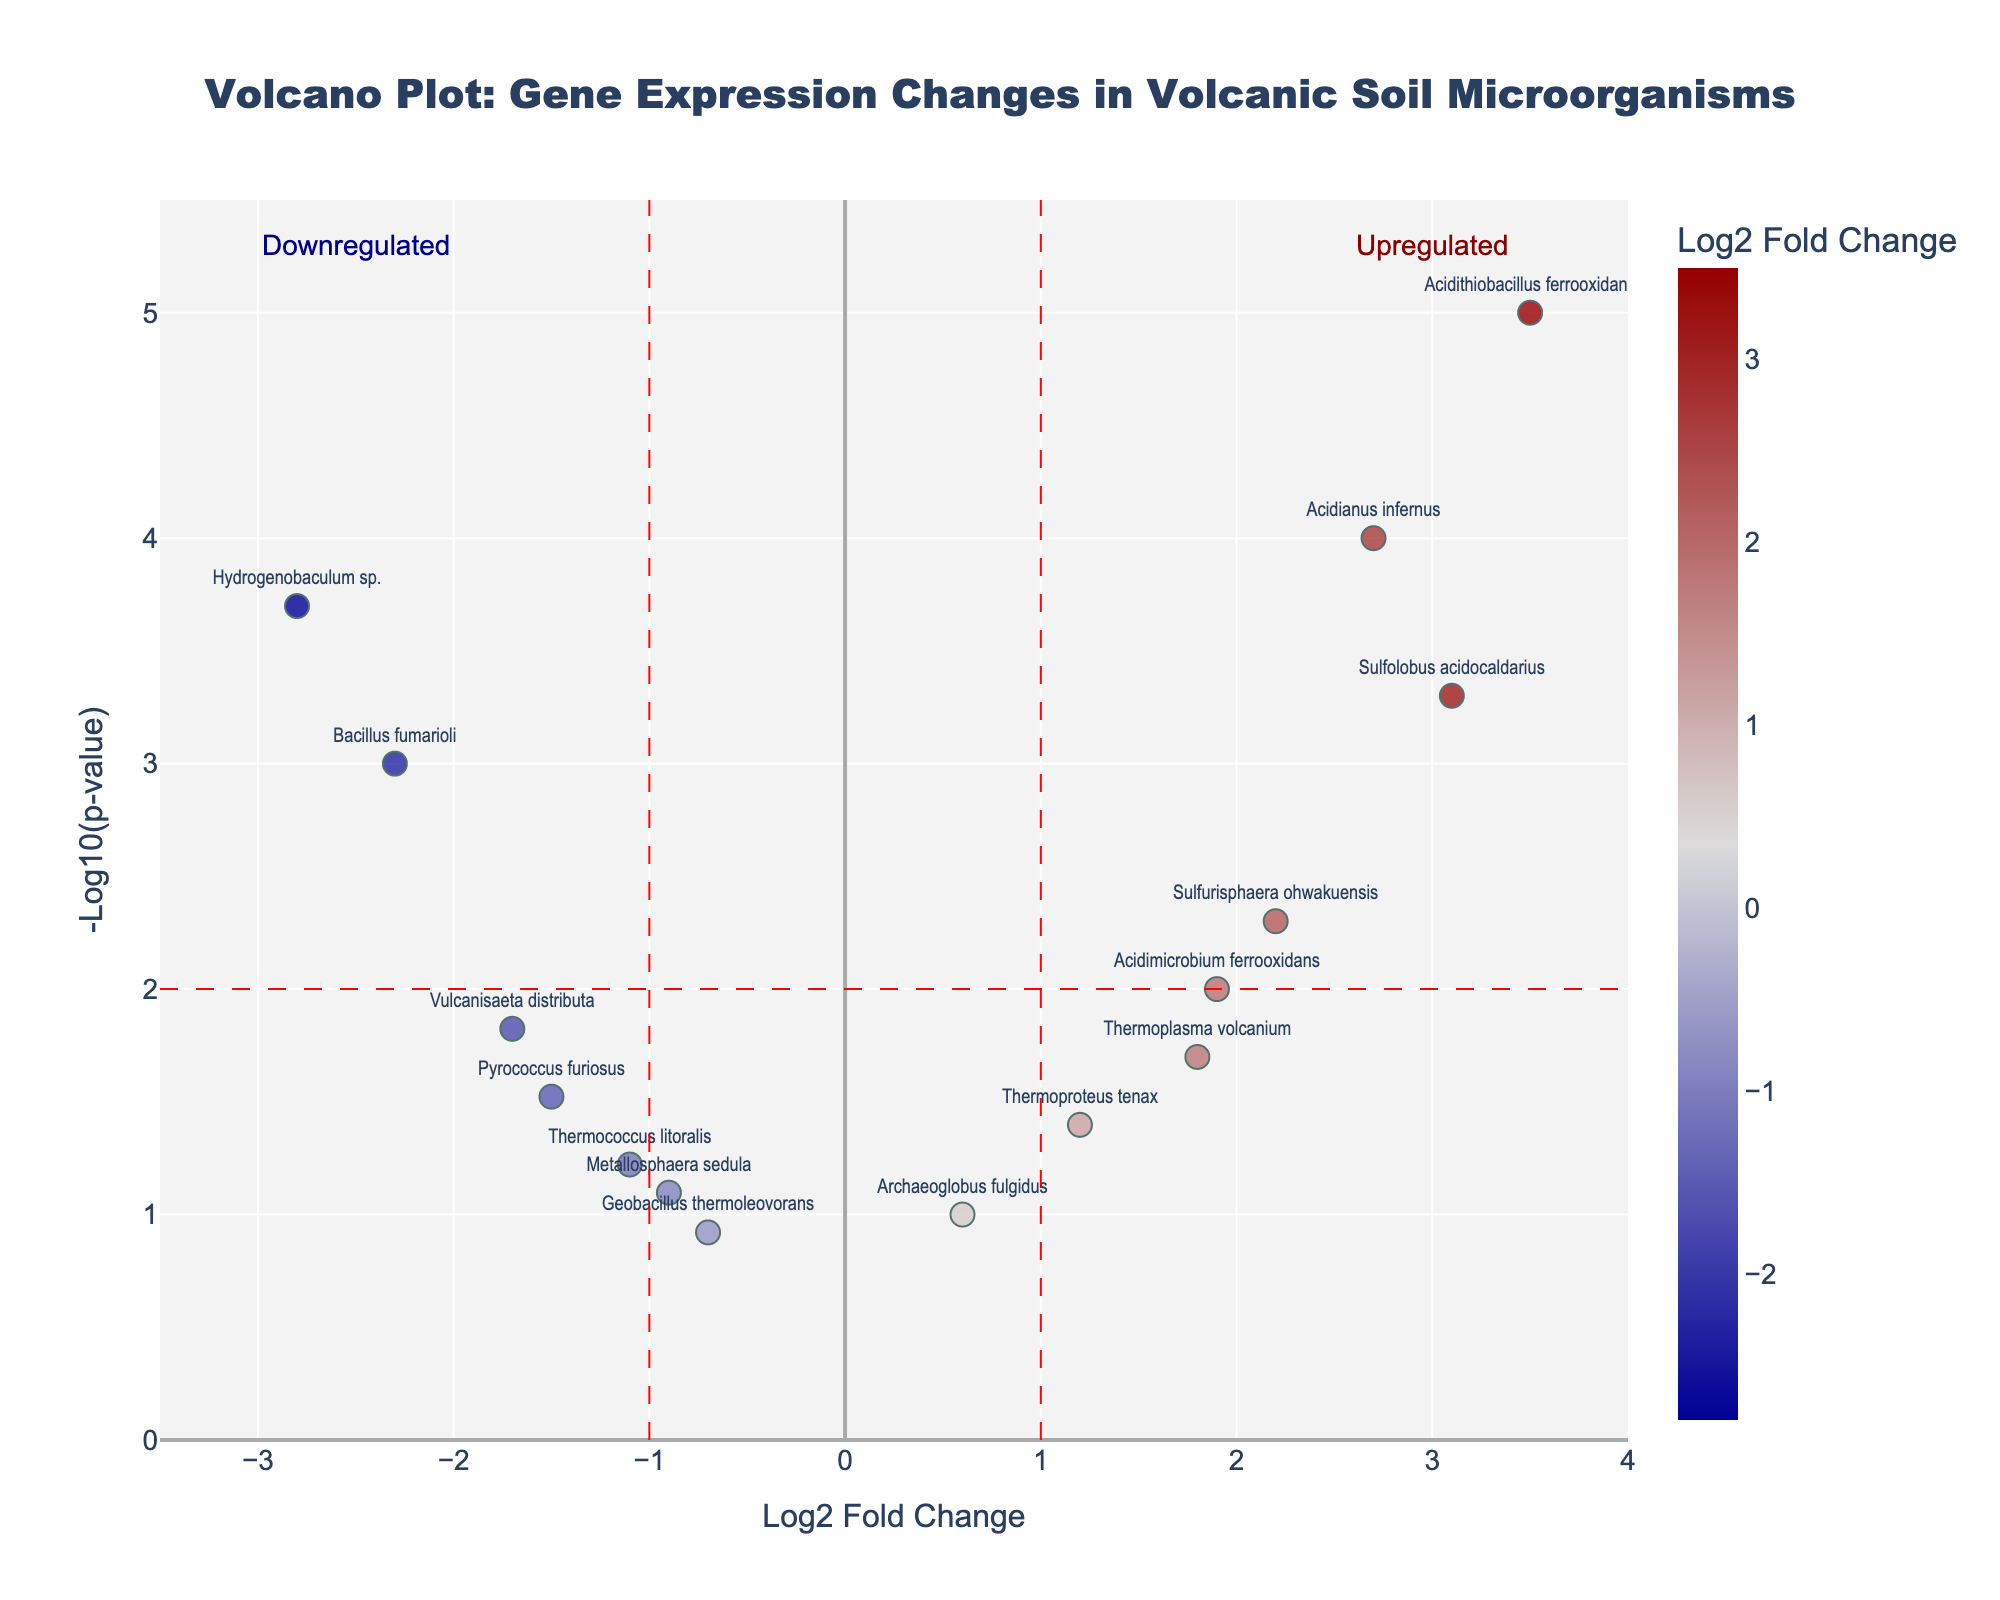What's the title of the plot? The title of the plot is usually at the top center of the figure. Here it's "Volcano Plot: Gene Expression Changes in Volcanic Soil Microorganisms".
Answer: Volcano Plot: Gene Expression Changes in Volcanic Soil Microorganisms What do the x-axis and y-axis represent in this plot? Refer to the axis labels. The x-axis represents ‘Log2 Fold Change’, and the y-axis represents '-Log10(p-value)'.
Answer: x-axis: Log2 Fold Change, y-axis: -Log10(p-value) Which gene has the highest Log2 Fold Change? By looking at the rightmost data points along the x-axis, 'Acidithiobacillus ferrooxidans' has the highest Log2 Fold Change.
Answer: Acidithiobacillus ferrooxidans Which gene is most significantly upregulated? 'Upregulated' refers to positive Log2 Fold Change values; the significance is shown by lower p-values (high -log10(p-value)). 'Acidithiobacillus ferrooxidans' has the highest value on the y-axis among upregulated genes.
Answer: Acidithiobacillus ferrooxidans How many genes have a -Log10(p-value) greater than or equal to 2? Count the data points above the horizontal threshold line y=2. There are 6 genes above this line.
Answer: 6 Among 'Sulfolobus acidocaldarius' and 'Thermoplasma volcanium', which gene is more significant in expression changes? Check which of these two genes has a higher '-Log10(p-value)'. 'Sulfolobus acidocaldarius' has a higher -log10(p-value).
Answer: Sulfolobus acidocaldarius Is 'Hydrogenobaculum sp.' upregulated or downregulated? Check the Log2 Fold Change for 'Hydrogenobaculum sp.'. Since it is negative, the gene is downregulated.
Answer: Downregulated What is the Log2 Fold Change range shown in the plot? Identify the range of the x-axis. The range edges are indicated at -3.5 (left) to 4 (right).
Answer: -3.5 to 4 What is the critical -Log10(p-value) threshold in this plot? Identify the horizontal dashed red line or refer to the added shapes. The threshold for -log10(p-value) is set at 2.
Answer: 2 How many genes are labeled in the plot? Count the number of text labels visible in the figure. There are 14 gene labels visible in the plot.
Answer: 14 